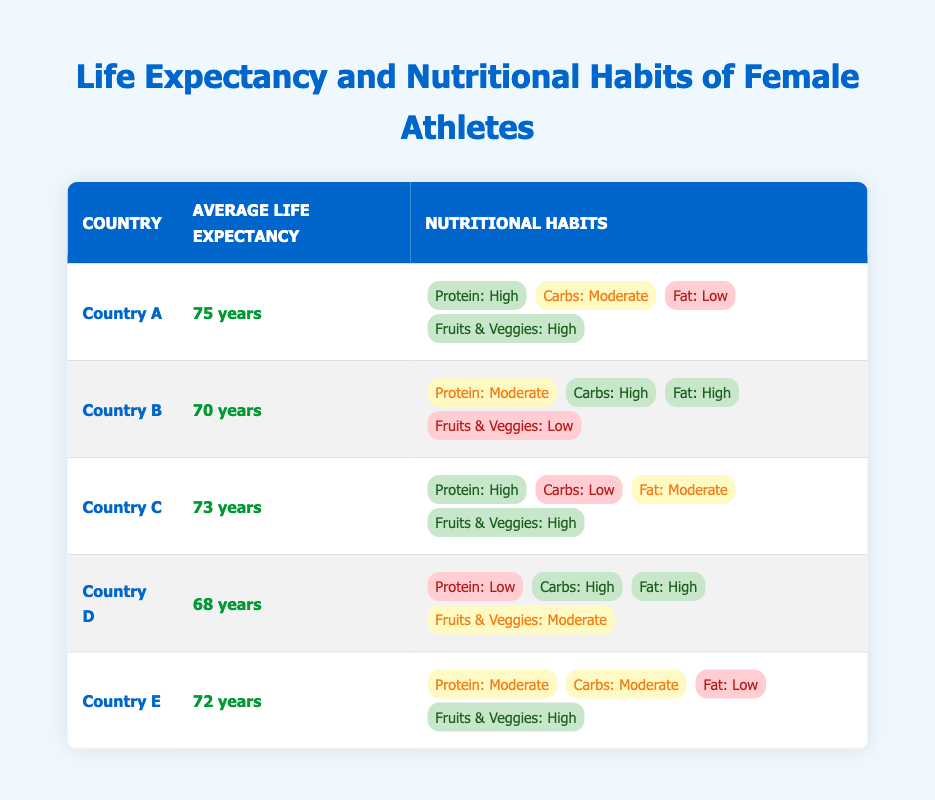What's the highest average life expectancy in the table? From the table, Country A has the highest average life expectancy at 75 years.
Answer: 75 years Which country has a low protein intake and high carbohydrate intake? Country D has a low protein intake and a high carbohydrate intake according to its nutritional habits in the table.
Answer: Country D How many countries have a high intake of fruits and vegetables? Looking at the table, Countries A, C, and E all have a high intake of fruits and vegetables, amounting to three countries in total.
Answer: 3 countries What is the average life expectancy of countries with high protein intake? The countries with high protein intake are A (75), C (73), giving us a total of 75 + 73 = 148. To find the average, we divide 148 by the number of countries, which is 2, resulting in an average of 74 years.
Answer: 74 years Does Country B have low fruit and vegetable consumption? Yes, Country B is marked with low fruit and vegetable consumption in the nutritional habits section of the table.
Answer: Yes Which country has the lowest life expectancy, and what are its nutritional habits? Country D has the lowest life expectancy at 68 years. Its nutritional habits include low protein intake, high carbohydrate intake, high fat intake, and moderate fruit and vegetable consumption.
Answer: Country D, nutritional habits: low protein, high carbohydrates, high fat, moderate fruits and vegetables Are there any countries with a moderate fat intake and high protein intake? Yes, Country C has a moderate fat intake while also maintaining a high protein intake according to the data outlined in the table.
Answer: Yes What is the average life expectancy of countries based on their carbohydrate intake levels? For high carbohydrate intake (Countries B and D), average equals (70 + 68) / 2 = 69 years. For moderate carbohydrate intake (Countries A and E), it equals (75 + 72) / 2 = 73.5 years. For low carbohydrate intake (Country C), it is specifically 73 years. Therefore, the average lifespans can be summarized.
Answer: High: 69 years, Moderate: 73.5 years, Low: 73 years Which country has high protein intake but low carbohydrate intake and what is its life expectancy? Country C has high protein intake and low carbohydrate intake, with an average life expectancy of 73 years according to the table.
Answer: Country C, 73 years 